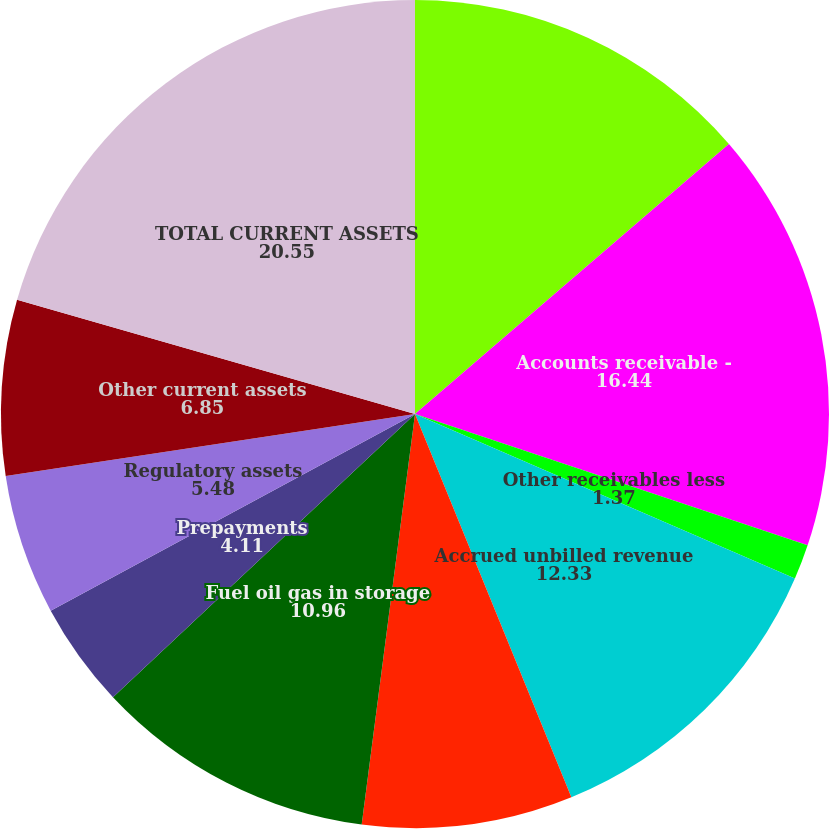Convert chart. <chart><loc_0><loc_0><loc_500><loc_500><pie_chart><fcel>Cash and temporary cash<fcel>Accounts receivable -<fcel>Other receivables less<fcel>Accrued unbilled revenue<fcel>Accounts receivable from<fcel>Fuel oil gas in storage<fcel>Prepayments<fcel>Regulatory assets<fcel>Other current assets<fcel>TOTAL CURRENT ASSETS<nl><fcel>13.7%<fcel>16.44%<fcel>1.37%<fcel>12.33%<fcel>8.22%<fcel>10.96%<fcel>4.11%<fcel>5.48%<fcel>6.85%<fcel>20.55%<nl></chart> 